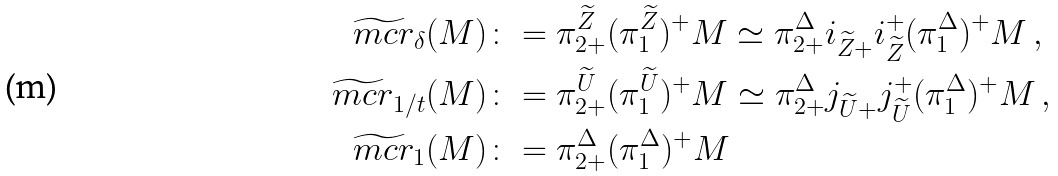<formula> <loc_0><loc_0><loc_500><loc_500>\widetilde { \ m c r } _ { \delta } ( M ) & \colon = \pi _ { 2 + } ^ { \widetilde { Z } } ( \pi _ { 1 } ^ { \widetilde { Z } } ) ^ { + } M \simeq \pi _ { 2 + } ^ { \Delta } i _ { \widetilde { Z } + } i _ { \widetilde { Z } } ^ { + } ( \pi _ { 1 } ^ { \Delta } ) ^ { + } M \, , \\ \widetilde { \ m c r } _ { 1 / t } ( M ) & \colon = \pi _ { 2 + } ^ { \widetilde { U } } ( \pi _ { 1 } ^ { \widetilde { U } } ) ^ { + } M \simeq \pi _ { 2 + } ^ { \Delta } j _ { \widetilde { U } + } j _ { \widetilde { U } } ^ { + } ( \pi _ { 1 } ^ { \Delta } ) ^ { + } M \, , \\ \widetilde { \ m c r } _ { 1 } ( M ) & \colon = \pi _ { 2 + } ^ { \Delta } ( \pi _ { 1 } ^ { \Delta } ) ^ { + } M</formula> 